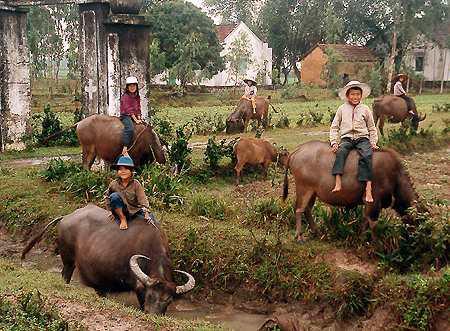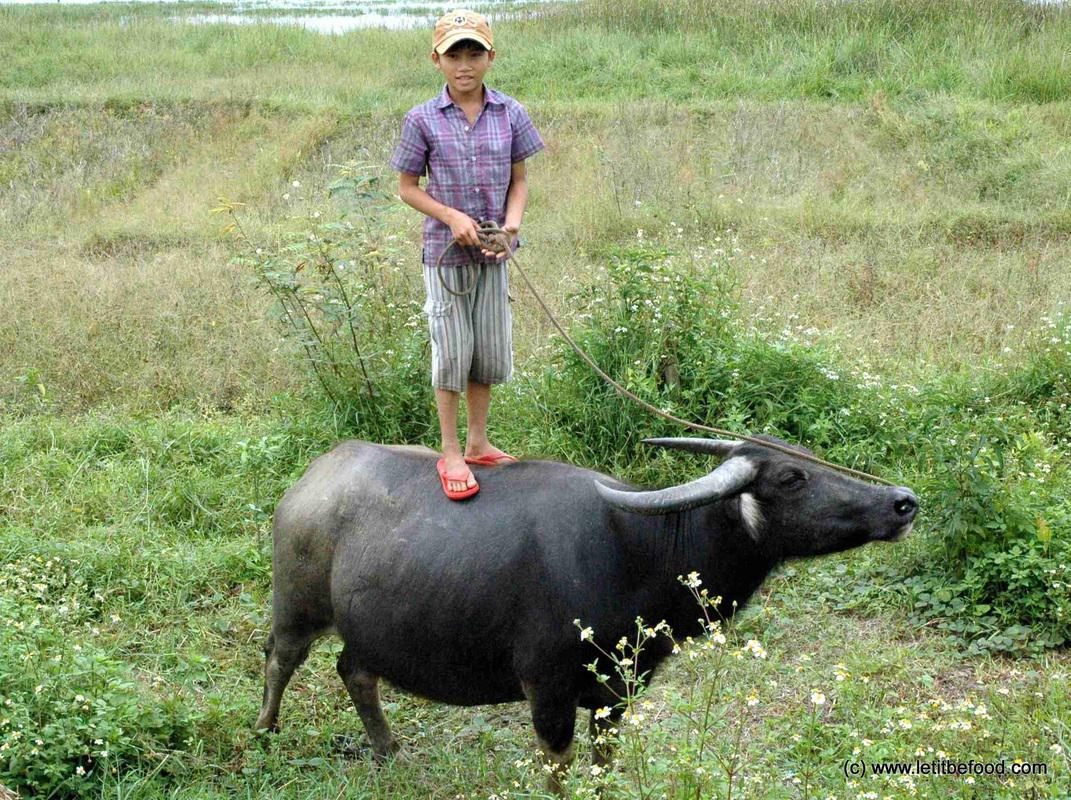The first image is the image on the left, the second image is the image on the right. Given the left and right images, does the statement "There is exactly one person sitting on an animal." hold true? Answer yes or no. No. The first image is the image on the left, the second image is the image on the right. For the images shown, is this caption "The combined images include multiple people wearing hats, multiple water buffalos, and at least one person wearing a hat while on top of a water buffalo." true? Answer yes or no. Yes. 